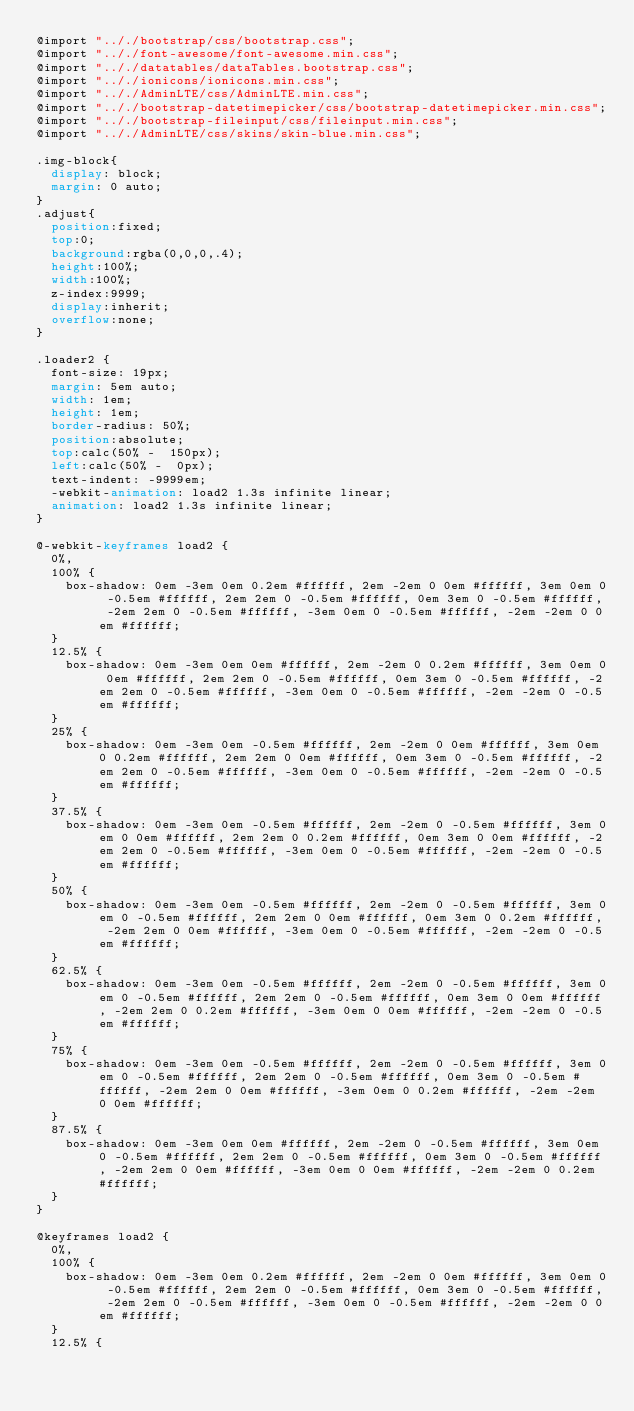Convert code to text. <code><loc_0><loc_0><loc_500><loc_500><_CSS_>@import ".././bootstrap/css/bootstrap.css";
@import ".././font-awesome/font-awesome.min.css";
@import ".././datatables/dataTables.bootstrap.css";
@import ".././ionicons/ionicons.min.css";
@import ".././AdminLTE/css/AdminLTE.min.css";
@import ".././bootstrap-datetimepicker/css/bootstrap-datetimepicker.min.css";
@import ".././bootstrap-fileinput/css/fileinput.min.css";
@import ".././AdminLTE/css/skins/skin-blue.min.css";

.img-block{
  display: block;
  margin: 0 auto;
}
.adjust{
	position:fixed;
  top:0;
  background:rgba(0,0,0,.4);
  height:100%;	
  width:100%;
  z-index:9999;
  display:inherit;
  overflow:none;
}

.loader2 {
  font-size: 19px;
  margin: 5em auto;
  width: 1em;
  height: 1em;
  border-radius: 50%;
  position:absolute;
  top:calc(50% -  150px);
  left:calc(50% -  0px);
  text-indent: -9999em;
  -webkit-animation: load2 1.3s infinite linear;
  animation: load2 1.3s infinite linear;
}

@-webkit-keyframes load2 {
  0%,
  100% {
    box-shadow: 0em -3em 0em 0.2em #ffffff, 2em -2em 0 0em #ffffff, 3em 0em 0 -0.5em #ffffff, 2em 2em 0 -0.5em #ffffff, 0em 3em 0 -0.5em #ffffff, -2em 2em 0 -0.5em #ffffff, -3em 0em 0 -0.5em #ffffff, -2em -2em 0 0em #ffffff;
  }
  12.5% {
    box-shadow: 0em -3em 0em 0em #ffffff, 2em -2em 0 0.2em #ffffff, 3em 0em 0 0em #ffffff, 2em 2em 0 -0.5em #ffffff, 0em 3em 0 -0.5em #ffffff, -2em 2em 0 -0.5em #ffffff, -3em 0em 0 -0.5em #ffffff, -2em -2em 0 -0.5em #ffffff;
  }
  25% {
    box-shadow: 0em -3em 0em -0.5em #ffffff, 2em -2em 0 0em #ffffff, 3em 0em 0 0.2em #ffffff, 2em 2em 0 0em #ffffff, 0em 3em 0 -0.5em #ffffff, -2em 2em 0 -0.5em #ffffff, -3em 0em 0 -0.5em #ffffff, -2em -2em 0 -0.5em #ffffff;
  }
  37.5% {
    box-shadow: 0em -3em 0em -0.5em #ffffff, 2em -2em 0 -0.5em #ffffff, 3em 0em 0 0em #ffffff, 2em 2em 0 0.2em #ffffff, 0em 3em 0 0em #ffffff, -2em 2em 0 -0.5em #ffffff, -3em 0em 0 -0.5em #ffffff, -2em -2em 0 -0.5em #ffffff;
  }
  50% {
    box-shadow: 0em -3em 0em -0.5em #ffffff, 2em -2em 0 -0.5em #ffffff, 3em 0em 0 -0.5em #ffffff, 2em 2em 0 0em #ffffff, 0em 3em 0 0.2em #ffffff, -2em 2em 0 0em #ffffff, -3em 0em 0 -0.5em #ffffff, -2em -2em 0 -0.5em #ffffff;
  }
  62.5% {
    box-shadow: 0em -3em 0em -0.5em #ffffff, 2em -2em 0 -0.5em #ffffff, 3em 0em 0 -0.5em #ffffff, 2em 2em 0 -0.5em #ffffff, 0em 3em 0 0em #ffffff, -2em 2em 0 0.2em #ffffff, -3em 0em 0 0em #ffffff, -2em -2em 0 -0.5em #ffffff;
  }
  75% {
    box-shadow: 0em -3em 0em -0.5em #ffffff, 2em -2em 0 -0.5em #ffffff, 3em 0em 0 -0.5em #ffffff, 2em 2em 0 -0.5em #ffffff, 0em 3em 0 -0.5em #ffffff, -2em 2em 0 0em #ffffff, -3em 0em 0 0.2em #ffffff, -2em -2em 0 0em #ffffff;
  }
  87.5% {
    box-shadow: 0em -3em 0em 0em #ffffff, 2em -2em 0 -0.5em #ffffff, 3em 0em 0 -0.5em #ffffff, 2em 2em 0 -0.5em #ffffff, 0em 3em 0 -0.5em #ffffff, -2em 2em 0 0em #ffffff, -3em 0em 0 0em #ffffff, -2em -2em 0 0.2em #ffffff;
  }
}

@keyframes load2 {
  0%,
  100% {
    box-shadow: 0em -3em 0em 0.2em #ffffff, 2em -2em 0 0em #ffffff, 3em 0em 0 -0.5em #ffffff, 2em 2em 0 -0.5em #ffffff, 0em 3em 0 -0.5em #ffffff, -2em 2em 0 -0.5em #ffffff, -3em 0em 0 -0.5em #ffffff, -2em -2em 0 0em #ffffff;
  }
  12.5% {</code> 